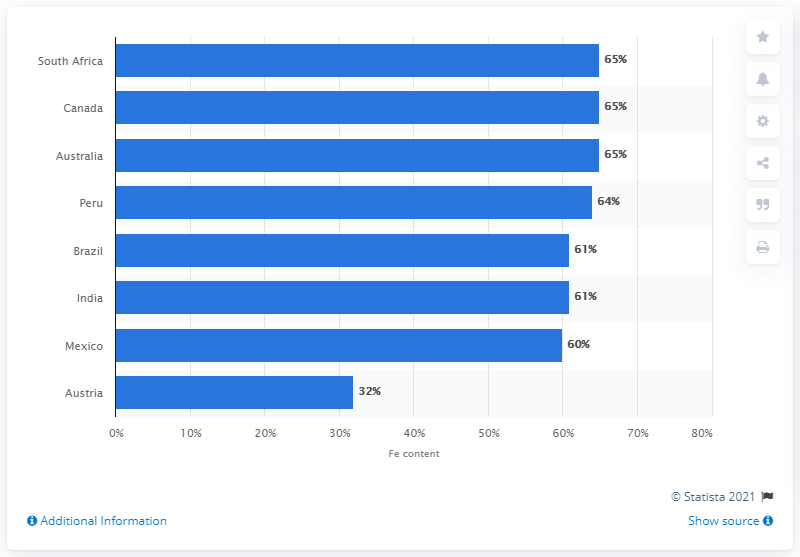Draw attention to some important aspects in this diagram. South Africa was one of the leading producers of iron ore in 2012. 